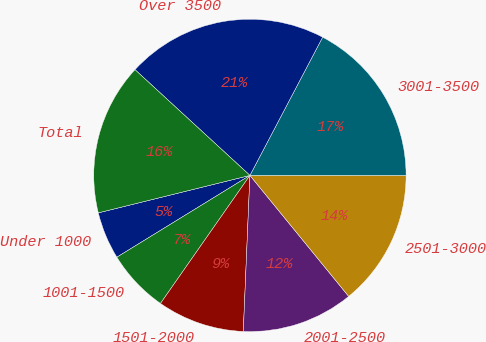Convert chart to OTSL. <chart><loc_0><loc_0><loc_500><loc_500><pie_chart><fcel>Under 1000<fcel>1001-1500<fcel>1501-2000<fcel>2001-2500<fcel>2501-3000<fcel>3001-3500<fcel>Over 3500<fcel>Total<nl><fcel>4.92%<fcel>6.52%<fcel>9.03%<fcel>11.57%<fcel>14.1%<fcel>17.29%<fcel>20.87%<fcel>15.69%<nl></chart> 